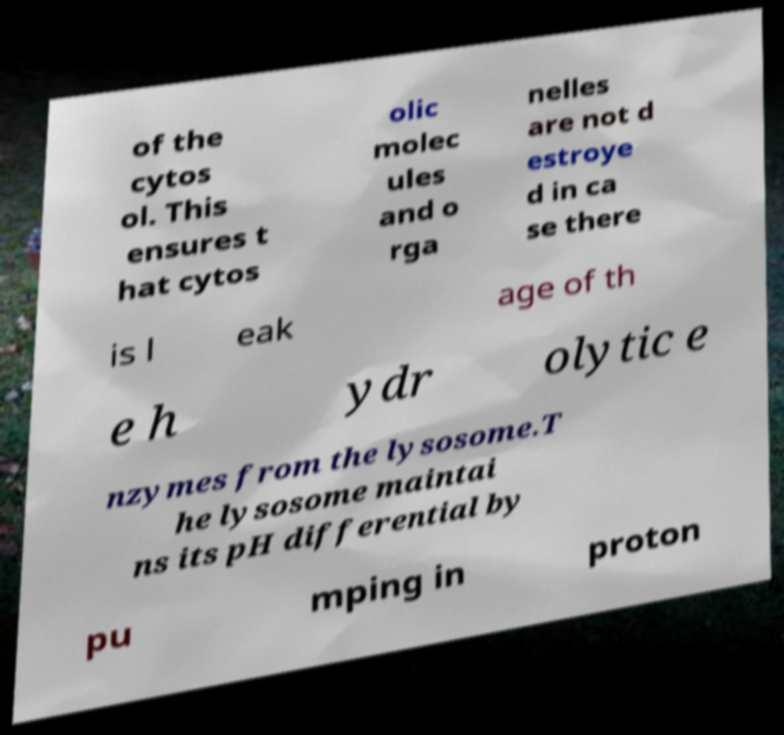What messages or text are displayed in this image? I need them in a readable, typed format. of the cytos ol. This ensures t hat cytos olic molec ules and o rga nelles are not d estroye d in ca se there is l eak age of th e h ydr olytic e nzymes from the lysosome.T he lysosome maintai ns its pH differential by pu mping in proton 